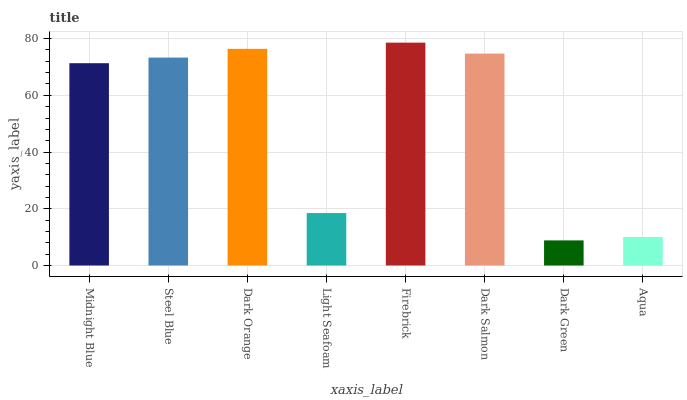Is Dark Green the minimum?
Answer yes or no. Yes. Is Firebrick the maximum?
Answer yes or no. Yes. Is Steel Blue the minimum?
Answer yes or no. No. Is Steel Blue the maximum?
Answer yes or no. No. Is Steel Blue greater than Midnight Blue?
Answer yes or no. Yes. Is Midnight Blue less than Steel Blue?
Answer yes or no. Yes. Is Midnight Blue greater than Steel Blue?
Answer yes or no. No. Is Steel Blue less than Midnight Blue?
Answer yes or no. No. Is Steel Blue the high median?
Answer yes or no. Yes. Is Midnight Blue the low median?
Answer yes or no. Yes. Is Firebrick the high median?
Answer yes or no. No. Is Dark Orange the low median?
Answer yes or no. No. 